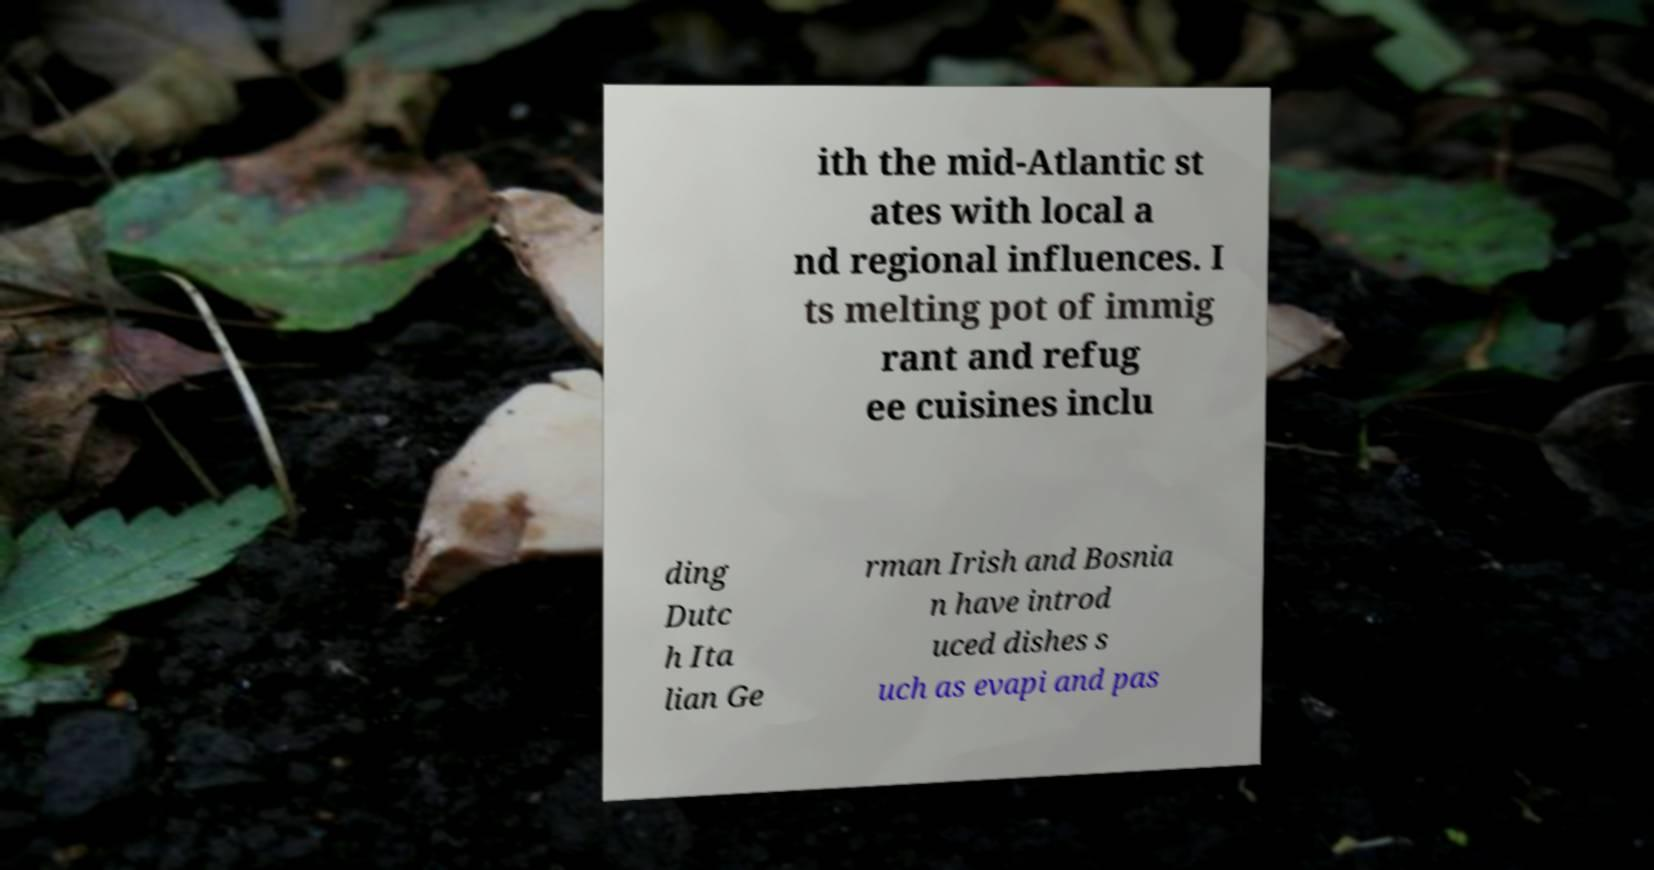Could you assist in decoding the text presented in this image and type it out clearly? ith the mid-Atlantic st ates with local a nd regional influences. I ts melting pot of immig rant and refug ee cuisines inclu ding Dutc h Ita lian Ge rman Irish and Bosnia n have introd uced dishes s uch as evapi and pas 